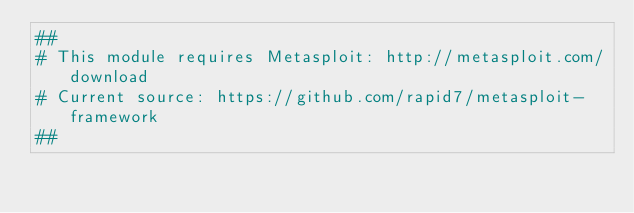Convert code to text. <code><loc_0><loc_0><loc_500><loc_500><_Ruby_>##
# This module requires Metasploit: http://metasploit.com/download
# Current source: https://github.com/rapid7/metasploit-framework
##
</code> 